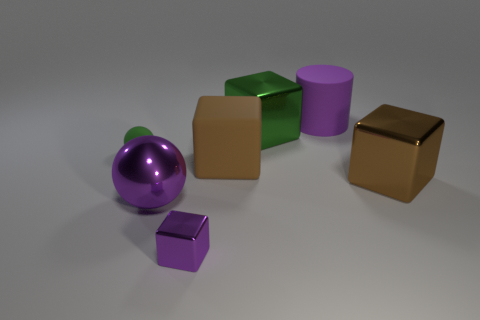What is the shape of the purple metal thing that is the same size as the rubber block?
Your answer should be compact. Sphere. Does the rubber sphere have the same color as the large object that is left of the purple shiny block?
Keep it short and to the point. No. What number of things are shiny things behind the big purple metallic sphere or green objects that are right of the large purple metal object?
Provide a succinct answer. 2. There is a green object that is the same size as the purple ball; what is it made of?
Your answer should be compact. Metal. How many other things are the same material as the tiny purple thing?
Keep it short and to the point. 3. Does the big green object behind the matte block have the same shape as the brown thing right of the big rubber cylinder?
Provide a succinct answer. Yes. What is the color of the metal cube behind the brown block that is to the right of the big purple object on the right side of the large brown rubber thing?
Keep it short and to the point. Green. What number of other things are there of the same color as the tiny block?
Make the answer very short. 2. Are there fewer small blue matte balls than small green spheres?
Your answer should be very brief. Yes. What color is the large metallic thing that is on the right side of the big purple metal thing and in front of the small green matte ball?
Offer a terse response. Brown. 